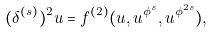Convert formula to latex. <formula><loc_0><loc_0><loc_500><loc_500>( \delta ^ { ( s ) } ) ^ { 2 } u = f ^ { ( 2 ) } ( u , u ^ { \phi ^ { s } } , u ^ { \phi ^ { 2 s } } ) ,</formula> 